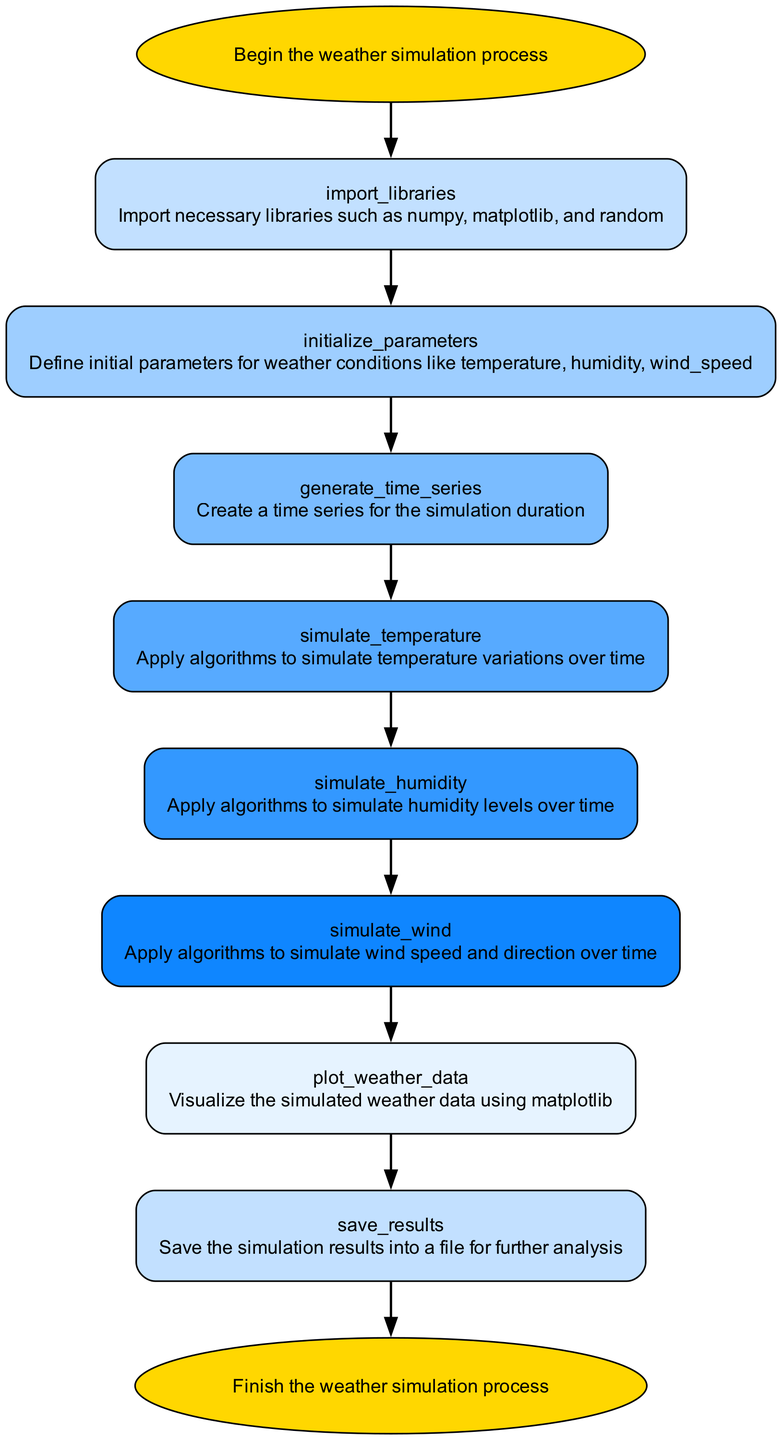What is the starting point of the weather simulation process? The diagram indicates that the starting point is labeled "start," which represents the first step in the flowchart.
Answer: start Which libraries are imported for the simulation? The node labeled "import_libraries" describes that necessary libraries such as numpy, matplotlib, and random are imported in this step.
Answer: numpy, matplotlib, random How many nodes are there in total? By counting each unique box representing different steps, there are ten nodes in total as laid out sequentially in the diagram.
Answer: ten What is the purpose of the node "plot_weather_data"? The description under the node "plot_weather_data" explains that it is used to visualize the simulated weather data using matplotlib, which is a key part of the data analysis process.
Answer: Visualize weather data What is the final step of the simulation process? The last node titled "end" indicates that this is the termination point of the weather simulation process, signifying that all steps have been completed.
Answer: end Which node comes after "simulate_temperature"? The flow of the diagram shows that after "simulate_temperature," the next node in the sequence is "simulate_humidity," indicating the sequential progression of the simulation steps.
Answer: simulate_humidity Describe the relationship between "generate_time_series" and "simulate_wind". "generate_time_series" is positioned earlier in the diagram and serves as a precursor step, indicating that a time series must be created before "simulate_wind" can be processed, as the wind simulation relies on the time series data.
Answer: Preceding step What type of data is saved in the "save_results" node? The node "save_results" indicates that the results generated during the simulation, which include the parameters and visualizations of the weather conditions, are saved into a file for further analysis purposes.
Answer: Simulation results Why is it essential to import libraries at the beginning? Importing libraries at the beginning, as shown in the "import_libraries" node, is essential for utilizing pre-built functions and algorithms necessary for data manipulations and visualizations throughout the simulation process.
Answer: Essential for functions 